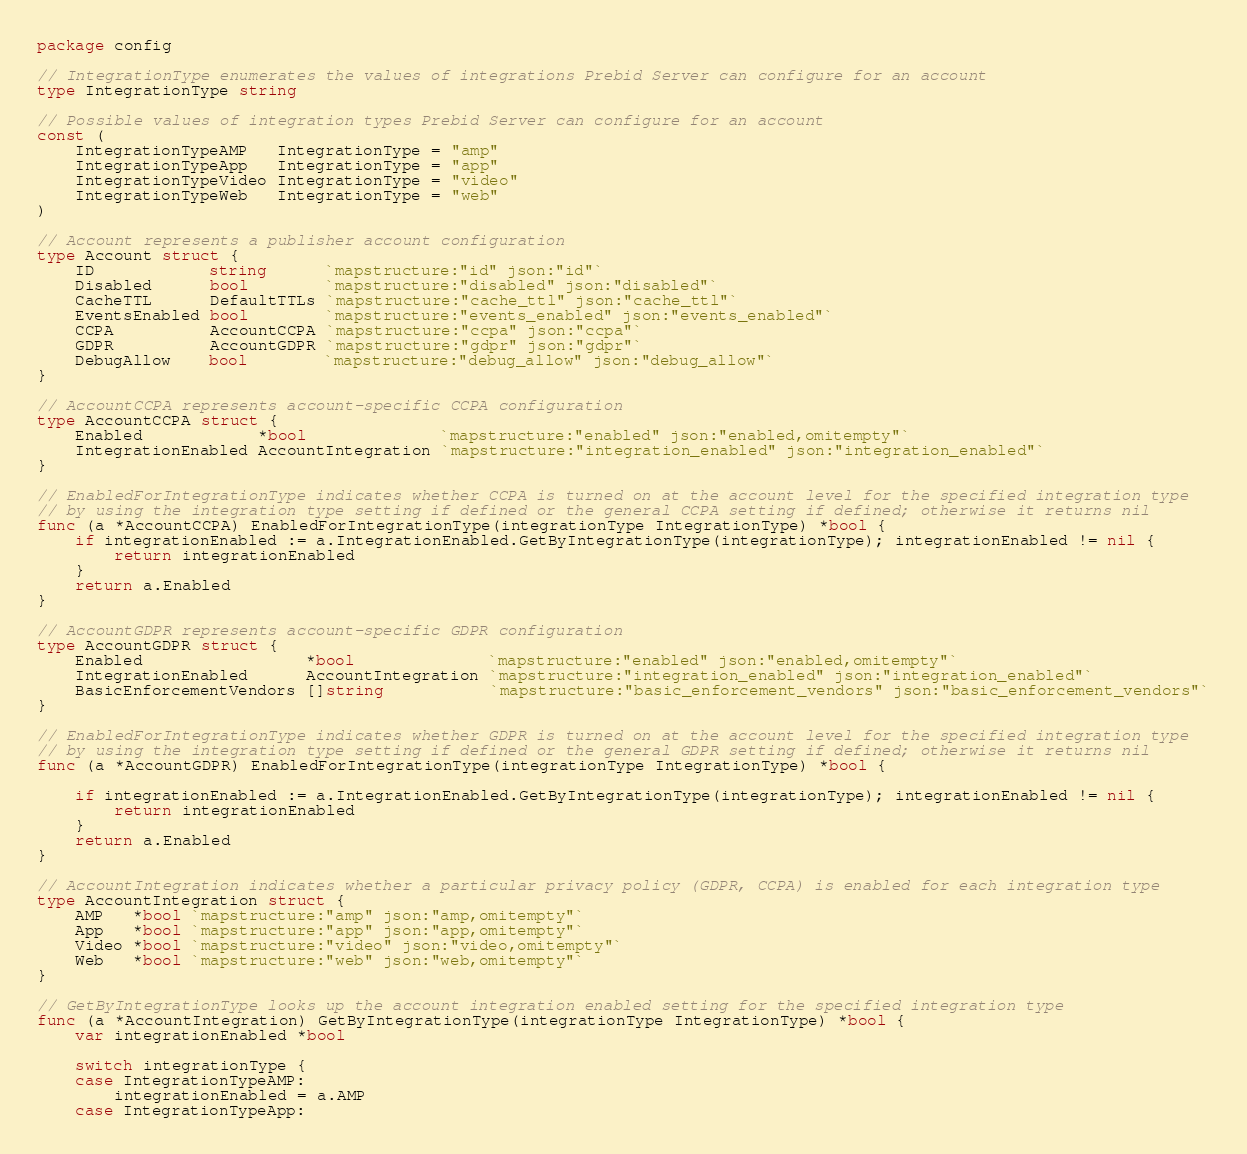Convert code to text. <code><loc_0><loc_0><loc_500><loc_500><_Go_>package config

// IntegrationType enumerates the values of integrations Prebid Server can configure for an account
type IntegrationType string

// Possible values of integration types Prebid Server can configure for an account
const (
	IntegrationTypeAMP   IntegrationType = "amp"
	IntegrationTypeApp   IntegrationType = "app"
	IntegrationTypeVideo IntegrationType = "video"
	IntegrationTypeWeb   IntegrationType = "web"
)

// Account represents a publisher account configuration
type Account struct {
	ID            string      `mapstructure:"id" json:"id"`
	Disabled      bool        `mapstructure:"disabled" json:"disabled"`
	CacheTTL      DefaultTTLs `mapstructure:"cache_ttl" json:"cache_ttl"`
	EventsEnabled bool        `mapstructure:"events_enabled" json:"events_enabled"`
	CCPA          AccountCCPA `mapstructure:"ccpa" json:"ccpa"`
	GDPR          AccountGDPR `mapstructure:"gdpr" json:"gdpr"`
	DebugAllow    bool        `mapstructure:"debug_allow" json:"debug_allow"`
}

// AccountCCPA represents account-specific CCPA configuration
type AccountCCPA struct {
	Enabled            *bool              `mapstructure:"enabled" json:"enabled,omitempty"`
	IntegrationEnabled AccountIntegration `mapstructure:"integration_enabled" json:"integration_enabled"`
}

// EnabledForIntegrationType indicates whether CCPA is turned on at the account level for the specified integration type
// by using the integration type setting if defined or the general CCPA setting if defined; otherwise it returns nil
func (a *AccountCCPA) EnabledForIntegrationType(integrationType IntegrationType) *bool {
	if integrationEnabled := a.IntegrationEnabled.GetByIntegrationType(integrationType); integrationEnabled != nil {
		return integrationEnabled
	}
	return a.Enabled
}

// AccountGDPR represents account-specific GDPR configuration
type AccountGDPR struct {
	Enabled                 *bool              `mapstructure:"enabled" json:"enabled,omitempty"`
	IntegrationEnabled      AccountIntegration `mapstructure:"integration_enabled" json:"integration_enabled"`
	BasicEnforcementVendors []string           `mapstructure:"basic_enforcement_vendors" json:"basic_enforcement_vendors"`
}

// EnabledForIntegrationType indicates whether GDPR is turned on at the account level for the specified integration type
// by using the integration type setting if defined or the general GDPR setting if defined; otherwise it returns nil
func (a *AccountGDPR) EnabledForIntegrationType(integrationType IntegrationType) *bool {

	if integrationEnabled := a.IntegrationEnabled.GetByIntegrationType(integrationType); integrationEnabled != nil {
		return integrationEnabled
	}
	return a.Enabled
}

// AccountIntegration indicates whether a particular privacy policy (GDPR, CCPA) is enabled for each integration type
type AccountIntegration struct {
	AMP   *bool `mapstructure:"amp" json:"amp,omitempty"`
	App   *bool `mapstructure:"app" json:"app,omitempty"`
	Video *bool `mapstructure:"video" json:"video,omitempty"`
	Web   *bool `mapstructure:"web" json:"web,omitempty"`
}

// GetByIntegrationType looks up the account integration enabled setting for the specified integration type
func (a *AccountIntegration) GetByIntegrationType(integrationType IntegrationType) *bool {
	var integrationEnabled *bool

	switch integrationType {
	case IntegrationTypeAMP:
		integrationEnabled = a.AMP
	case IntegrationTypeApp:</code> 